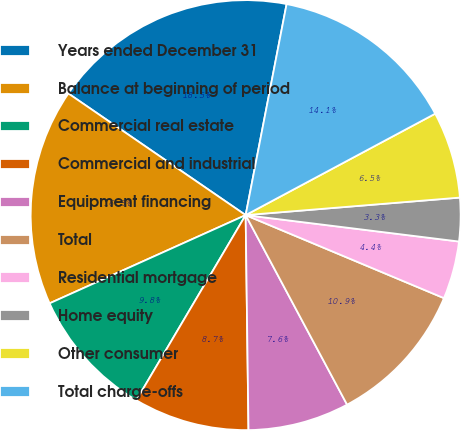Convert chart to OTSL. <chart><loc_0><loc_0><loc_500><loc_500><pie_chart><fcel>Years ended December 31<fcel>Balance at beginning of period<fcel>Commercial real estate<fcel>Commercial and industrial<fcel>Equipment financing<fcel>Total<fcel>Residential mortgage<fcel>Home equity<fcel>Other consumer<fcel>Total charge-offs<nl><fcel>18.48%<fcel>16.3%<fcel>9.78%<fcel>8.7%<fcel>7.61%<fcel>10.87%<fcel>4.35%<fcel>3.26%<fcel>6.52%<fcel>14.13%<nl></chart> 